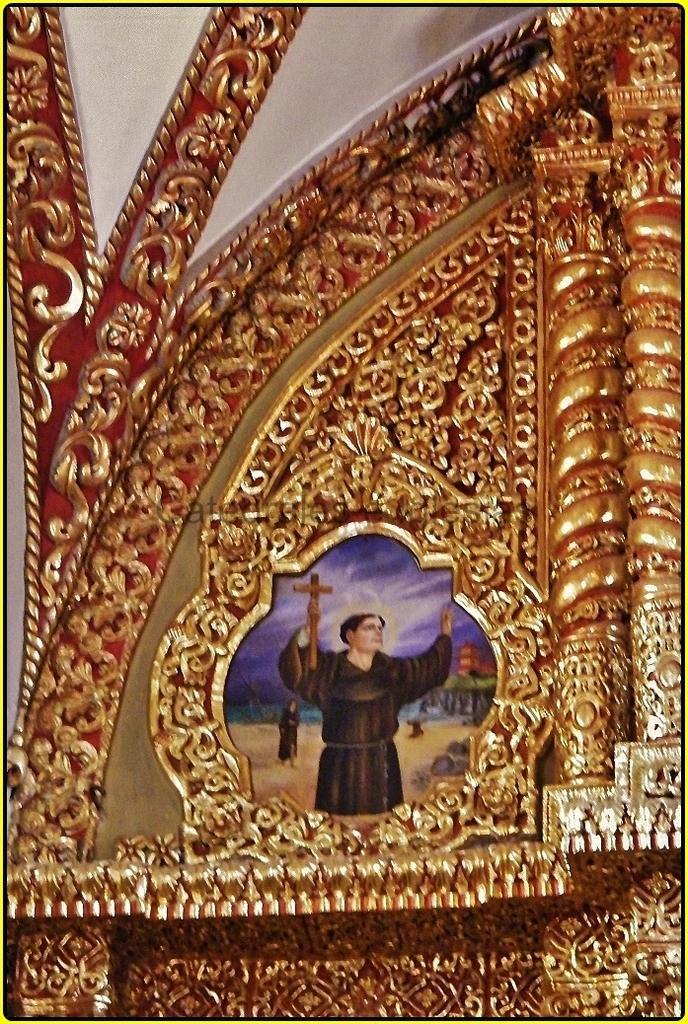Describe this image in one or two sentences. In this image, we can see a decorative frame and painting. In the painting, we can see a person is holding a holy cross. Top of the image, we can see white color. 